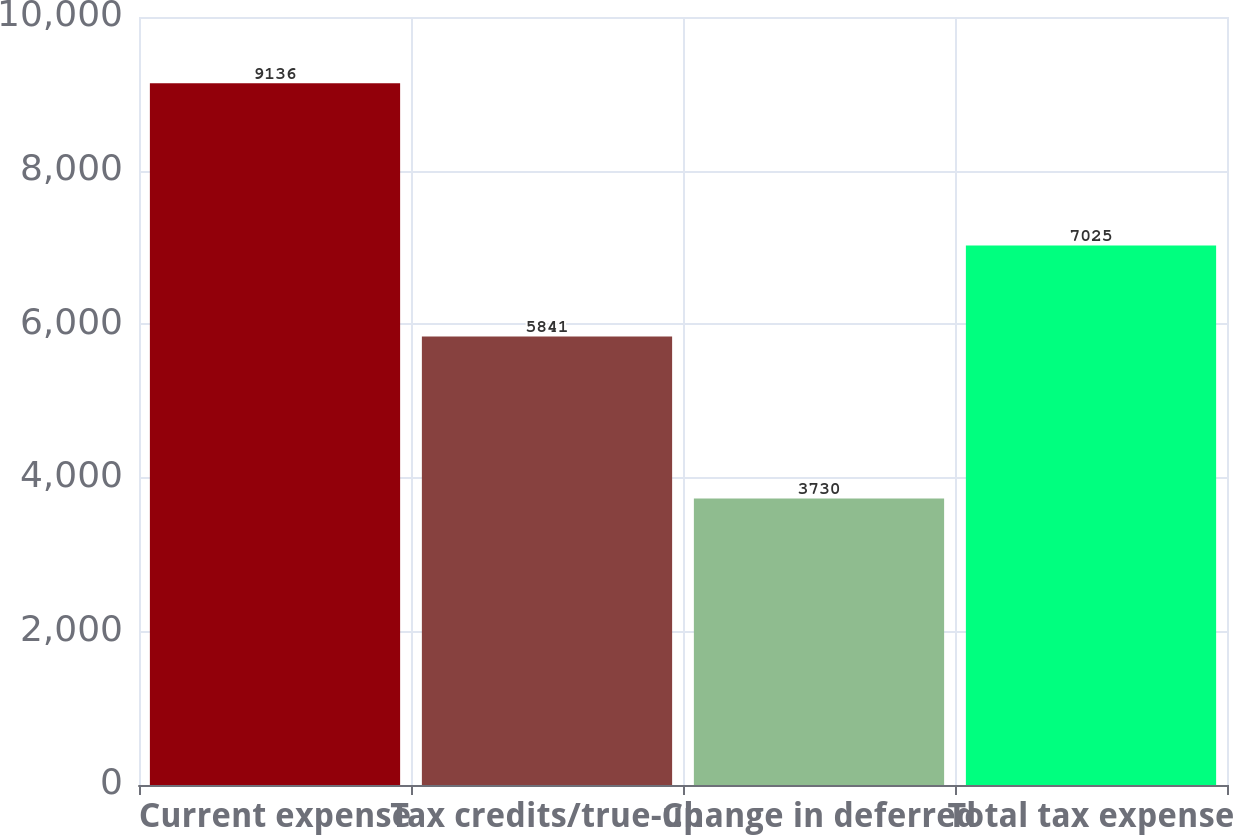<chart> <loc_0><loc_0><loc_500><loc_500><bar_chart><fcel>Current expense<fcel>Tax credits/true-up<fcel>Change in deferred<fcel>Total tax expense<nl><fcel>9136<fcel>5841<fcel>3730<fcel>7025<nl></chart> 